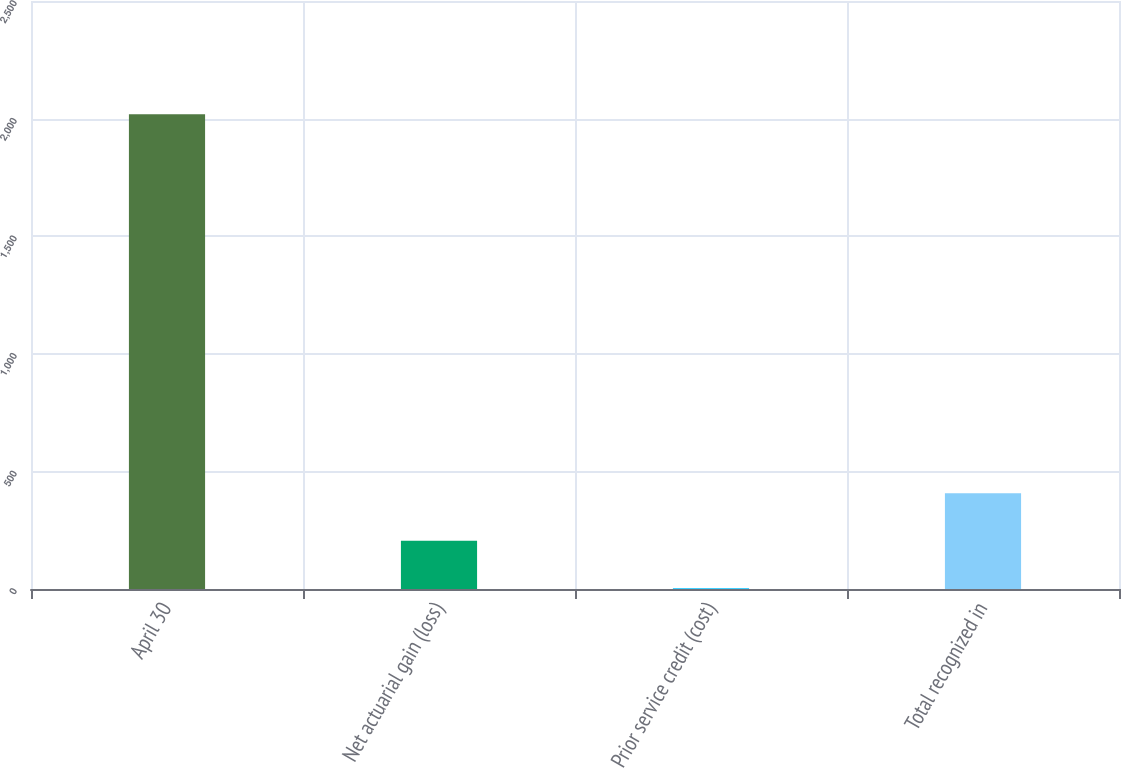<chart> <loc_0><loc_0><loc_500><loc_500><bar_chart><fcel>April 30<fcel>Net actuarial gain (loss)<fcel>Prior service credit (cost)<fcel>Total recognized in<nl><fcel>2019<fcel>205.05<fcel>3.5<fcel>406.6<nl></chart> 